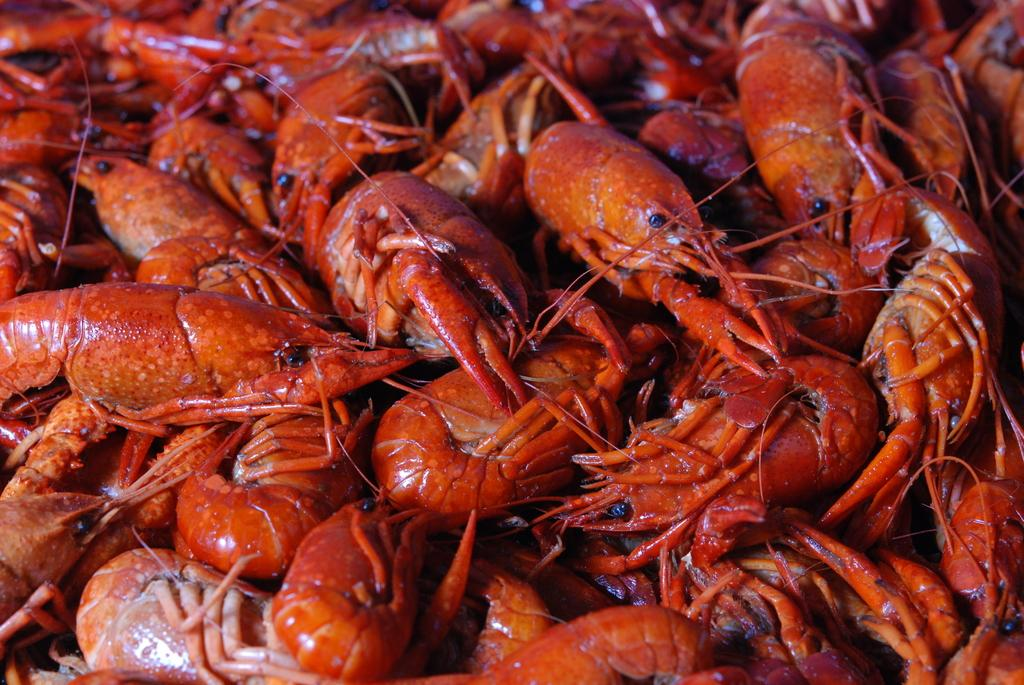What type of seafood can be seen in the image? There are shrimps present in the image. What type of haircut is the shrimp getting in the image? There is no haircut or shrimp getting a haircut in the image; it only features shrimps. 